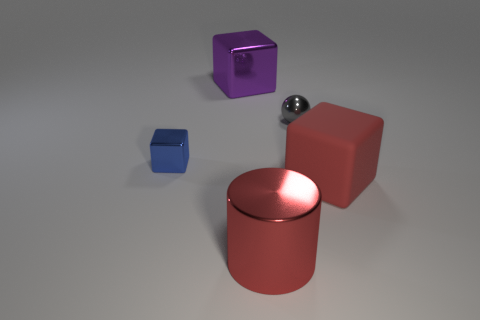Is there anything else that is made of the same material as the red cube?
Make the answer very short. No. Does the cylinder have the same color as the matte cube?
Offer a very short reply. Yes. What size is the matte object that is the same color as the cylinder?
Your response must be concise. Large. How many purple shiny things have the same shape as the tiny blue metallic object?
Make the answer very short. 1. There is a object that is the same size as the gray sphere; what shape is it?
Keep it short and to the point. Cube. Are there any small blue cubes behind the large purple metal cube?
Keep it short and to the point. No. Are there any purple blocks that are to the right of the big cube that is behind the red rubber thing?
Offer a very short reply. No. Are there fewer blocks on the right side of the large matte object than big metal objects that are behind the large purple shiny object?
Your response must be concise. No. Are there any other things that have the same size as the blue thing?
Provide a succinct answer. Yes. The small blue metal object has what shape?
Your answer should be very brief. Cube. 